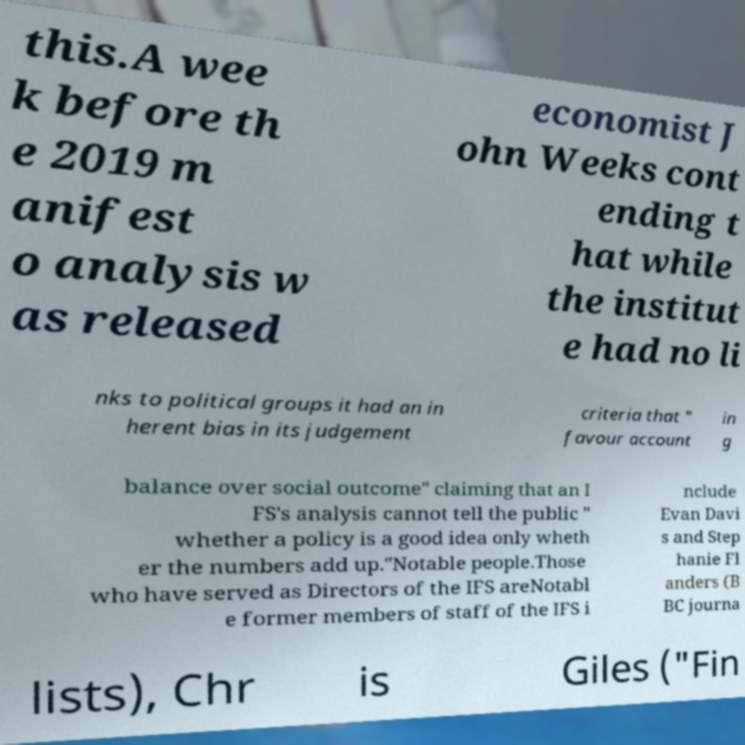Could you extract and type out the text from this image? this.A wee k before th e 2019 m anifest o analysis w as released economist J ohn Weeks cont ending t hat while the institut e had no li nks to political groups it had an in herent bias in its judgement criteria that " favour account in g balance over social outcome" claiming that an I FS's analysis cannot tell the public " whether a policy is a good idea only wheth er the numbers add up."Notable people.Those who have served as Directors of the IFS areNotabl e former members of staff of the IFS i nclude Evan Davi s and Step hanie Fl anders (B BC journa lists), Chr is Giles ("Fin 